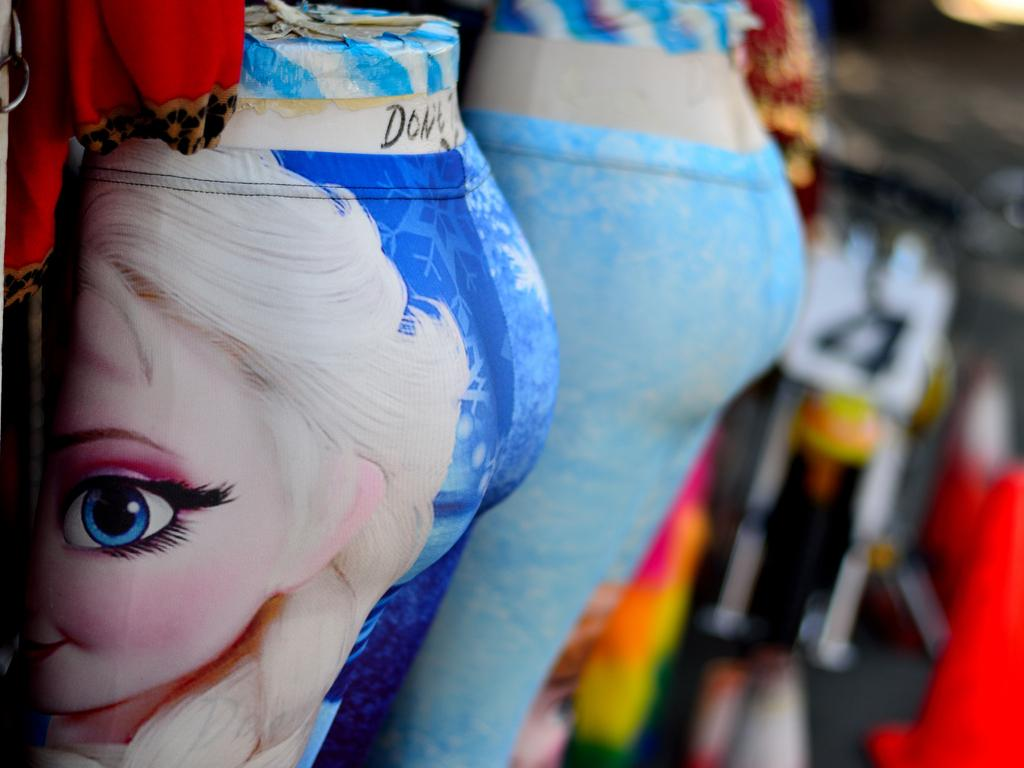What is the main subject of the image? There is a doll in the image. What type of clothing is the doll wearing? The doll is wearing pants. What is depicted on the doll's pants? There is an animation picture on the doll's pants. What type of committee is responsible for the plot of the animation picture on the doll's pants? There is no committee or plot mentioned in the image; it only features a doll with animation-themed pants. 